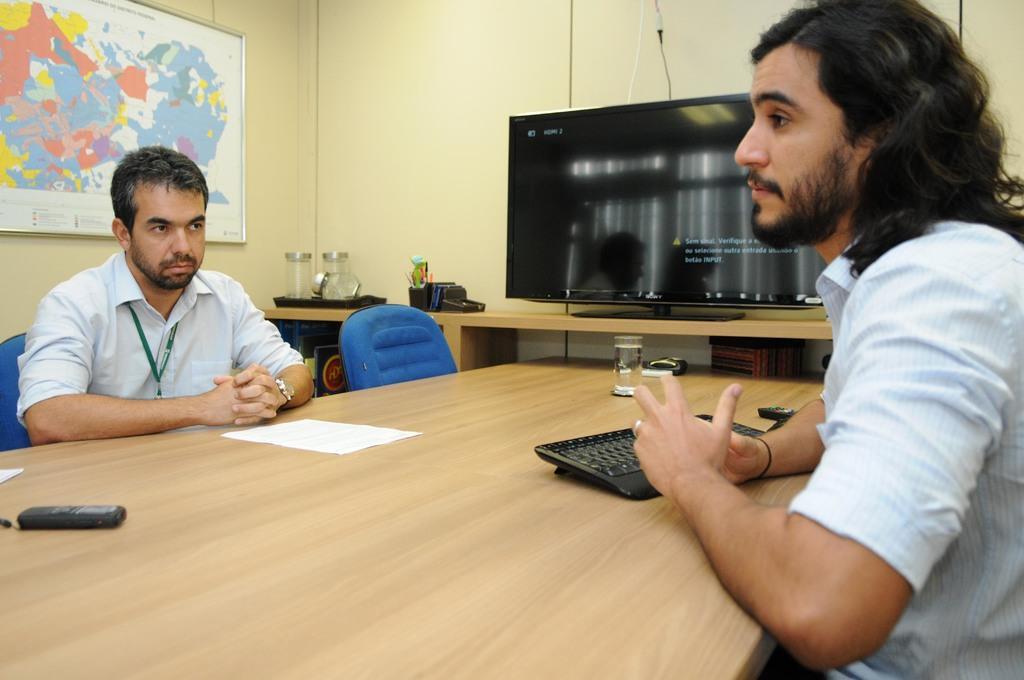Could you give a brief overview of what you see in this image? There are two people sitting on a chair. There is a table. There is a pen,mobile and glass on a table. Nin background world map and TV. 